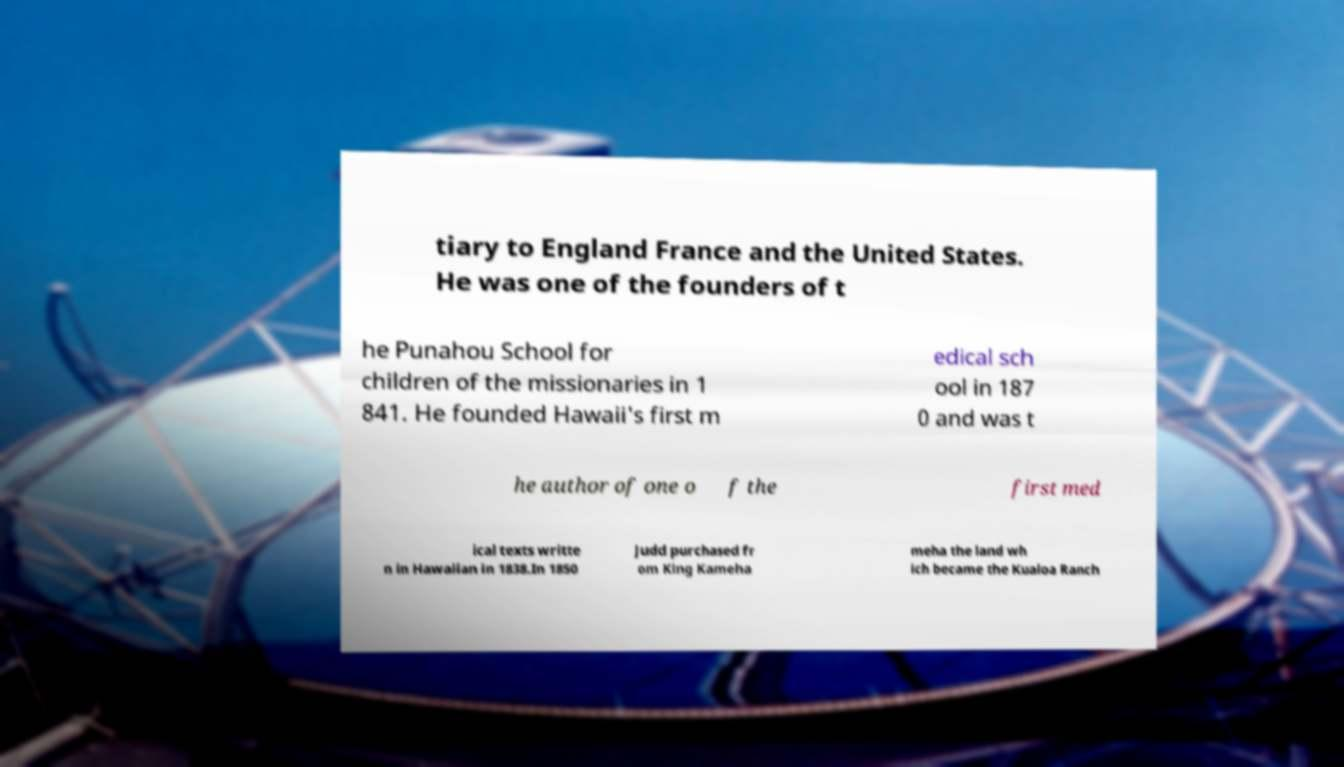Could you extract and type out the text from this image? tiary to England France and the United States. He was one of the founders of t he Punahou School for children of the missionaries in 1 841. He founded Hawaii's first m edical sch ool in 187 0 and was t he author of one o f the first med ical texts writte n in Hawaiian in 1838.In 1850 Judd purchased fr om King Kameha meha the land wh ich became the Kualoa Ranch 